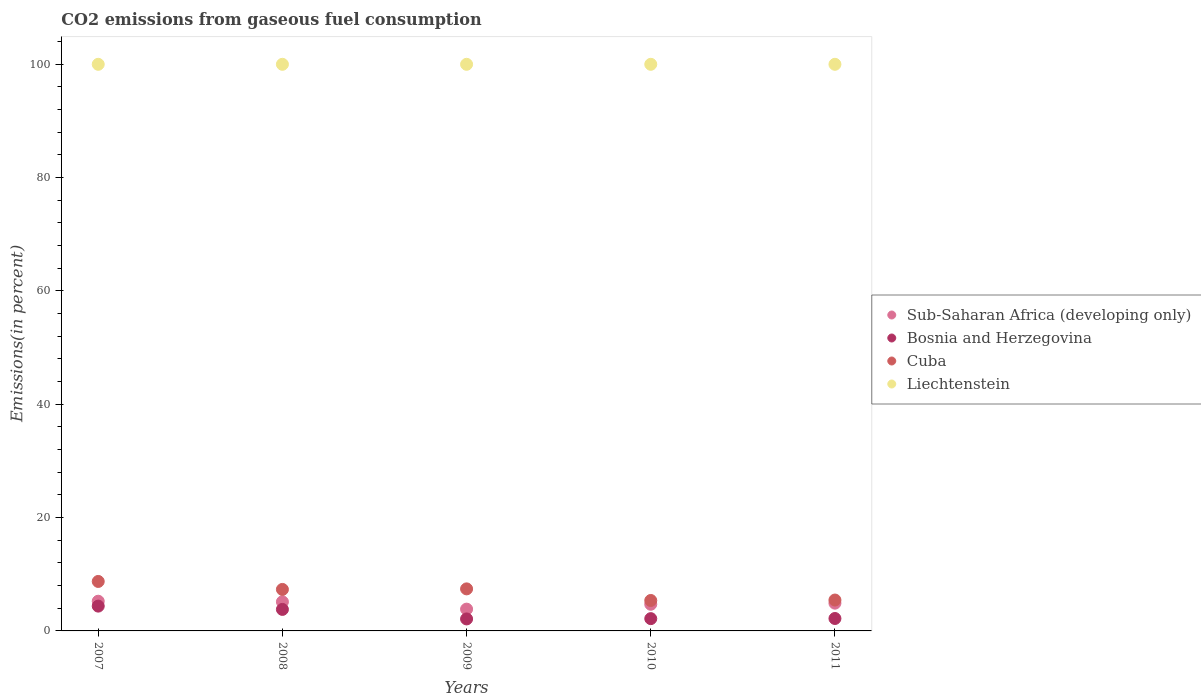What is the total CO2 emitted in Bosnia and Herzegovina in 2007?
Your answer should be very brief. 4.38. Across all years, what is the maximum total CO2 emitted in Bosnia and Herzegovina?
Offer a terse response. 4.38. Across all years, what is the minimum total CO2 emitted in Bosnia and Herzegovina?
Keep it short and to the point. 2.12. In which year was the total CO2 emitted in Liechtenstein maximum?
Give a very brief answer. 2007. In which year was the total CO2 emitted in Sub-Saharan Africa (developing only) minimum?
Your response must be concise. 2009. What is the total total CO2 emitted in Liechtenstein in the graph?
Offer a very short reply. 500. What is the difference between the total CO2 emitted in Cuba in 2009 and that in 2010?
Give a very brief answer. 2.05. What is the difference between the total CO2 emitted in Cuba in 2008 and the total CO2 emitted in Liechtenstein in 2007?
Keep it short and to the point. -92.68. What is the average total CO2 emitted in Bosnia and Herzegovina per year?
Your response must be concise. 2.93. In the year 2007, what is the difference between the total CO2 emitted in Bosnia and Herzegovina and total CO2 emitted in Liechtenstein?
Your response must be concise. -95.62. In how many years, is the total CO2 emitted in Liechtenstein greater than 32 %?
Ensure brevity in your answer.  5. What is the ratio of the total CO2 emitted in Sub-Saharan Africa (developing only) in 2009 to that in 2011?
Provide a succinct answer. 0.79. Is the total CO2 emitted in Bosnia and Herzegovina in 2010 less than that in 2011?
Offer a very short reply. Yes. What is the difference between the highest and the second highest total CO2 emitted in Bosnia and Herzegovina?
Provide a succinct answer. 0.58. Is the sum of the total CO2 emitted in Liechtenstein in 2009 and 2011 greater than the maximum total CO2 emitted in Sub-Saharan Africa (developing only) across all years?
Ensure brevity in your answer.  Yes. Is it the case that in every year, the sum of the total CO2 emitted in Cuba and total CO2 emitted in Liechtenstein  is greater than the total CO2 emitted in Sub-Saharan Africa (developing only)?
Offer a very short reply. Yes. Does the total CO2 emitted in Bosnia and Herzegovina monotonically increase over the years?
Offer a terse response. No. Is the total CO2 emitted in Liechtenstein strictly greater than the total CO2 emitted in Sub-Saharan Africa (developing only) over the years?
Give a very brief answer. Yes. How many dotlines are there?
Offer a very short reply. 4. How many years are there in the graph?
Make the answer very short. 5. What is the difference between two consecutive major ticks on the Y-axis?
Keep it short and to the point. 20. Are the values on the major ticks of Y-axis written in scientific E-notation?
Offer a terse response. No. Does the graph contain any zero values?
Give a very brief answer. No. Where does the legend appear in the graph?
Your response must be concise. Center right. How many legend labels are there?
Your answer should be very brief. 4. How are the legend labels stacked?
Keep it short and to the point. Vertical. What is the title of the graph?
Offer a very short reply. CO2 emissions from gaseous fuel consumption. What is the label or title of the X-axis?
Provide a succinct answer. Years. What is the label or title of the Y-axis?
Provide a succinct answer. Emissions(in percent). What is the Emissions(in percent) of Sub-Saharan Africa (developing only) in 2007?
Your answer should be compact. 5.24. What is the Emissions(in percent) in Bosnia and Herzegovina in 2007?
Ensure brevity in your answer.  4.38. What is the Emissions(in percent) of Cuba in 2007?
Your answer should be very brief. 8.73. What is the Emissions(in percent) in Liechtenstein in 2007?
Your response must be concise. 100. What is the Emissions(in percent) of Sub-Saharan Africa (developing only) in 2008?
Give a very brief answer. 5.14. What is the Emissions(in percent) of Bosnia and Herzegovina in 2008?
Offer a terse response. 3.8. What is the Emissions(in percent) in Cuba in 2008?
Ensure brevity in your answer.  7.32. What is the Emissions(in percent) of Liechtenstein in 2008?
Keep it short and to the point. 100. What is the Emissions(in percent) of Sub-Saharan Africa (developing only) in 2009?
Keep it short and to the point. 3.85. What is the Emissions(in percent) of Bosnia and Herzegovina in 2009?
Provide a succinct answer. 2.12. What is the Emissions(in percent) in Cuba in 2009?
Your answer should be very brief. 7.42. What is the Emissions(in percent) in Liechtenstein in 2009?
Ensure brevity in your answer.  100. What is the Emissions(in percent) of Sub-Saharan Africa (developing only) in 2010?
Offer a very short reply. 4.71. What is the Emissions(in percent) of Bosnia and Herzegovina in 2010?
Your response must be concise. 2.17. What is the Emissions(in percent) of Cuba in 2010?
Keep it short and to the point. 5.37. What is the Emissions(in percent) of Liechtenstein in 2010?
Your answer should be very brief. 100. What is the Emissions(in percent) of Sub-Saharan Africa (developing only) in 2011?
Provide a succinct answer. 4.9. What is the Emissions(in percent) of Bosnia and Herzegovina in 2011?
Make the answer very short. 2.19. What is the Emissions(in percent) in Cuba in 2011?
Your response must be concise. 5.45. What is the Emissions(in percent) in Liechtenstein in 2011?
Offer a very short reply. 100. Across all years, what is the maximum Emissions(in percent) in Sub-Saharan Africa (developing only)?
Provide a succinct answer. 5.24. Across all years, what is the maximum Emissions(in percent) of Bosnia and Herzegovina?
Offer a very short reply. 4.38. Across all years, what is the maximum Emissions(in percent) of Cuba?
Provide a short and direct response. 8.73. Across all years, what is the minimum Emissions(in percent) of Sub-Saharan Africa (developing only)?
Your answer should be very brief. 3.85. Across all years, what is the minimum Emissions(in percent) in Bosnia and Herzegovina?
Your response must be concise. 2.12. Across all years, what is the minimum Emissions(in percent) in Cuba?
Offer a very short reply. 5.37. What is the total Emissions(in percent) of Sub-Saharan Africa (developing only) in the graph?
Your response must be concise. 23.83. What is the total Emissions(in percent) in Bosnia and Herzegovina in the graph?
Keep it short and to the point. 14.65. What is the total Emissions(in percent) of Cuba in the graph?
Your answer should be compact. 34.3. What is the total Emissions(in percent) of Liechtenstein in the graph?
Make the answer very short. 500. What is the difference between the Emissions(in percent) in Sub-Saharan Africa (developing only) in 2007 and that in 2008?
Offer a very short reply. 0.1. What is the difference between the Emissions(in percent) in Bosnia and Herzegovina in 2007 and that in 2008?
Keep it short and to the point. 0.58. What is the difference between the Emissions(in percent) of Cuba in 2007 and that in 2008?
Provide a succinct answer. 1.41. What is the difference between the Emissions(in percent) of Liechtenstein in 2007 and that in 2008?
Ensure brevity in your answer.  0. What is the difference between the Emissions(in percent) of Sub-Saharan Africa (developing only) in 2007 and that in 2009?
Provide a short and direct response. 1.39. What is the difference between the Emissions(in percent) in Bosnia and Herzegovina in 2007 and that in 2009?
Give a very brief answer. 2.26. What is the difference between the Emissions(in percent) of Cuba in 2007 and that in 2009?
Offer a very short reply. 1.31. What is the difference between the Emissions(in percent) in Liechtenstein in 2007 and that in 2009?
Offer a very short reply. 0. What is the difference between the Emissions(in percent) of Sub-Saharan Africa (developing only) in 2007 and that in 2010?
Your answer should be compact. 0.54. What is the difference between the Emissions(in percent) of Bosnia and Herzegovina in 2007 and that in 2010?
Offer a terse response. 2.21. What is the difference between the Emissions(in percent) in Cuba in 2007 and that in 2010?
Make the answer very short. 3.36. What is the difference between the Emissions(in percent) of Sub-Saharan Africa (developing only) in 2007 and that in 2011?
Keep it short and to the point. 0.34. What is the difference between the Emissions(in percent) in Bosnia and Herzegovina in 2007 and that in 2011?
Your response must be concise. 2.19. What is the difference between the Emissions(in percent) of Cuba in 2007 and that in 2011?
Offer a very short reply. 3.28. What is the difference between the Emissions(in percent) of Sub-Saharan Africa (developing only) in 2008 and that in 2009?
Your response must be concise. 1.29. What is the difference between the Emissions(in percent) in Bosnia and Herzegovina in 2008 and that in 2009?
Give a very brief answer. 1.68. What is the difference between the Emissions(in percent) in Cuba in 2008 and that in 2009?
Offer a very short reply. -0.1. What is the difference between the Emissions(in percent) in Sub-Saharan Africa (developing only) in 2008 and that in 2010?
Your answer should be compact. 0.43. What is the difference between the Emissions(in percent) in Bosnia and Herzegovina in 2008 and that in 2010?
Your response must be concise. 1.63. What is the difference between the Emissions(in percent) of Cuba in 2008 and that in 2010?
Provide a short and direct response. 1.95. What is the difference between the Emissions(in percent) in Liechtenstein in 2008 and that in 2010?
Your answer should be compact. 0. What is the difference between the Emissions(in percent) of Sub-Saharan Africa (developing only) in 2008 and that in 2011?
Make the answer very short. 0.24. What is the difference between the Emissions(in percent) of Bosnia and Herzegovina in 2008 and that in 2011?
Keep it short and to the point. 1.6. What is the difference between the Emissions(in percent) in Cuba in 2008 and that in 2011?
Your answer should be very brief. 1.87. What is the difference between the Emissions(in percent) in Liechtenstein in 2008 and that in 2011?
Your response must be concise. 0. What is the difference between the Emissions(in percent) in Sub-Saharan Africa (developing only) in 2009 and that in 2010?
Offer a terse response. -0.86. What is the difference between the Emissions(in percent) of Bosnia and Herzegovina in 2009 and that in 2010?
Make the answer very short. -0.05. What is the difference between the Emissions(in percent) of Cuba in 2009 and that in 2010?
Provide a short and direct response. 2.05. What is the difference between the Emissions(in percent) of Sub-Saharan Africa (developing only) in 2009 and that in 2011?
Provide a succinct answer. -1.05. What is the difference between the Emissions(in percent) of Bosnia and Herzegovina in 2009 and that in 2011?
Offer a terse response. -0.08. What is the difference between the Emissions(in percent) of Cuba in 2009 and that in 2011?
Provide a succinct answer. 1.97. What is the difference between the Emissions(in percent) in Liechtenstein in 2009 and that in 2011?
Your answer should be very brief. 0. What is the difference between the Emissions(in percent) of Sub-Saharan Africa (developing only) in 2010 and that in 2011?
Keep it short and to the point. -0.19. What is the difference between the Emissions(in percent) in Bosnia and Herzegovina in 2010 and that in 2011?
Make the answer very short. -0.03. What is the difference between the Emissions(in percent) of Cuba in 2010 and that in 2011?
Your answer should be very brief. -0.08. What is the difference between the Emissions(in percent) of Sub-Saharan Africa (developing only) in 2007 and the Emissions(in percent) of Bosnia and Herzegovina in 2008?
Provide a succinct answer. 1.44. What is the difference between the Emissions(in percent) in Sub-Saharan Africa (developing only) in 2007 and the Emissions(in percent) in Cuba in 2008?
Your response must be concise. -2.08. What is the difference between the Emissions(in percent) in Sub-Saharan Africa (developing only) in 2007 and the Emissions(in percent) in Liechtenstein in 2008?
Offer a terse response. -94.76. What is the difference between the Emissions(in percent) of Bosnia and Herzegovina in 2007 and the Emissions(in percent) of Cuba in 2008?
Make the answer very short. -2.95. What is the difference between the Emissions(in percent) of Bosnia and Herzegovina in 2007 and the Emissions(in percent) of Liechtenstein in 2008?
Give a very brief answer. -95.62. What is the difference between the Emissions(in percent) of Cuba in 2007 and the Emissions(in percent) of Liechtenstein in 2008?
Offer a very short reply. -91.27. What is the difference between the Emissions(in percent) in Sub-Saharan Africa (developing only) in 2007 and the Emissions(in percent) in Bosnia and Herzegovina in 2009?
Provide a succinct answer. 3.12. What is the difference between the Emissions(in percent) in Sub-Saharan Africa (developing only) in 2007 and the Emissions(in percent) in Cuba in 2009?
Ensure brevity in your answer.  -2.18. What is the difference between the Emissions(in percent) of Sub-Saharan Africa (developing only) in 2007 and the Emissions(in percent) of Liechtenstein in 2009?
Your answer should be very brief. -94.76. What is the difference between the Emissions(in percent) of Bosnia and Herzegovina in 2007 and the Emissions(in percent) of Cuba in 2009?
Your answer should be compact. -3.04. What is the difference between the Emissions(in percent) in Bosnia and Herzegovina in 2007 and the Emissions(in percent) in Liechtenstein in 2009?
Your answer should be very brief. -95.62. What is the difference between the Emissions(in percent) of Cuba in 2007 and the Emissions(in percent) of Liechtenstein in 2009?
Provide a short and direct response. -91.27. What is the difference between the Emissions(in percent) of Sub-Saharan Africa (developing only) in 2007 and the Emissions(in percent) of Bosnia and Herzegovina in 2010?
Keep it short and to the point. 3.07. What is the difference between the Emissions(in percent) in Sub-Saharan Africa (developing only) in 2007 and the Emissions(in percent) in Cuba in 2010?
Offer a terse response. -0.13. What is the difference between the Emissions(in percent) in Sub-Saharan Africa (developing only) in 2007 and the Emissions(in percent) in Liechtenstein in 2010?
Keep it short and to the point. -94.76. What is the difference between the Emissions(in percent) of Bosnia and Herzegovina in 2007 and the Emissions(in percent) of Cuba in 2010?
Your answer should be very brief. -0.99. What is the difference between the Emissions(in percent) in Bosnia and Herzegovina in 2007 and the Emissions(in percent) in Liechtenstein in 2010?
Provide a succinct answer. -95.62. What is the difference between the Emissions(in percent) in Cuba in 2007 and the Emissions(in percent) in Liechtenstein in 2010?
Ensure brevity in your answer.  -91.27. What is the difference between the Emissions(in percent) of Sub-Saharan Africa (developing only) in 2007 and the Emissions(in percent) of Bosnia and Herzegovina in 2011?
Keep it short and to the point. 3.05. What is the difference between the Emissions(in percent) of Sub-Saharan Africa (developing only) in 2007 and the Emissions(in percent) of Cuba in 2011?
Keep it short and to the point. -0.21. What is the difference between the Emissions(in percent) in Sub-Saharan Africa (developing only) in 2007 and the Emissions(in percent) in Liechtenstein in 2011?
Provide a short and direct response. -94.76. What is the difference between the Emissions(in percent) in Bosnia and Herzegovina in 2007 and the Emissions(in percent) in Cuba in 2011?
Ensure brevity in your answer.  -1.07. What is the difference between the Emissions(in percent) in Bosnia and Herzegovina in 2007 and the Emissions(in percent) in Liechtenstein in 2011?
Keep it short and to the point. -95.62. What is the difference between the Emissions(in percent) of Cuba in 2007 and the Emissions(in percent) of Liechtenstein in 2011?
Provide a short and direct response. -91.27. What is the difference between the Emissions(in percent) of Sub-Saharan Africa (developing only) in 2008 and the Emissions(in percent) of Bosnia and Herzegovina in 2009?
Keep it short and to the point. 3.02. What is the difference between the Emissions(in percent) of Sub-Saharan Africa (developing only) in 2008 and the Emissions(in percent) of Cuba in 2009?
Provide a succinct answer. -2.28. What is the difference between the Emissions(in percent) of Sub-Saharan Africa (developing only) in 2008 and the Emissions(in percent) of Liechtenstein in 2009?
Provide a short and direct response. -94.86. What is the difference between the Emissions(in percent) in Bosnia and Herzegovina in 2008 and the Emissions(in percent) in Cuba in 2009?
Keep it short and to the point. -3.62. What is the difference between the Emissions(in percent) in Bosnia and Herzegovina in 2008 and the Emissions(in percent) in Liechtenstein in 2009?
Offer a very short reply. -96.2. What is the difference between the Emissions(in percent) in Cuba in 2008 and the Emissions(in percent) in Liechtenstein in 2009?
Provide a short and direct response. -92.68. What is the difference between the Emissions(in percent) in Sub-Saharan Africa (developing only) in 2008 and the Emissions(in percent) in Bosnia and Herzegovina in 2010?
Your answer should be compact. 2.97. What is the difference between the Emissions(in percent) of Sub-Saharan Africa (developing only) in 2008 and the Emissions(in percent) of Cuba in 2010?
Ensure brevity in your answer.  -0.23. What is the difference between the Emissions(in percent) of Sub-Saharan Africa (developing only) in 2008 and the Emissions(in percent) of Liechtenstein in 2010?
Keep it short and to the point. -94.86. What is the difference between the Emissions(in percent) of Bosnia and Herzegovina in 2008 and the Emissions(in percent) of Cuba in 2010?
Your response must be concise. -1.58. What is the difference between the Emissions(in percent) of Bosnia and Herzegovina in 2008 and the Emissions(in percent) of Liechtenstein in 2010?
Offer a terse response. -96.2. What is the difference between the Emissions(in percent) in Cuba in 2008 and the Emissions(in percent) in Liechtenstein in 2010?
Your answer should be compact. -92.68. What is the difference between the Emissions(in percent) in Sub-Saharan Africa (developing only) in 2008 and the Emissions(in percent) in Bosnia and Herzegovina in 2011?
Make the answer very short. 2.95. What is the difference between the Emissions(in percent) of Sub-Saharan Africa (developing only) in 2008 and the Emissions(in percent) of Cuba in 2011?
Your answer should be very brief. -0.31. What is the difference between the Emissions(in percent) in Sub-Saharan Africa (developing only) in 2008 and the Emissions(in percent) in Liechtenstein in 2011?
Ensure brevity in your answer.  -94.86. What is the difference between the Emissions(in percent) of Bosnia and Herzegovina in 2008 and the Emissions(in percent) of Cuba in 2011?
Your answer should be compact. -1.65. What is the difference between the Emissions(in percent) in Bosnia and Herzegovina in 2008 and the Emissions(in percent) in Liechtenstein in 2011?
Ensure brevity in your answer.  -96.2. What is the difference between the Emissions(in percent) in Cuba in 2008 and the Emissions(in percent) in Liechtenstein in 2011?
Your answer should be compact. -92.68. What is the difference between the Emissions(in percent) in Sub-Saharan Africa (developing only) in 2009 and the Emissions(in percent) in Bosnia and Herzegovina in 2010?
Ensure brevity in your answer.  1.68. What is the difference between the Emissions(in percent) of Sub-Saharan Africa (developing only) in 2009 and the Emissions(in percent) of Cuba in 2010?
Offer a very short reply. -1.53. What is the difference between the Emissions(in percent) in Sub-Saharan Africa (developing only) in 2009 and the Emissions(in percent) in Liechtenstein in 2010?
Your answer should be very brief. -96.15. What is the difference between the Emissions(in percent) of Bosnia and Herzegovina in 2009 and the Emissions(in percent) of Cuba in 2010?
Ensure brevity in your answer.  -3.26. What is the difference between the Emissions(in percent) of Bosnia and Herzegovina in 2009 and the Emissions(in percent) of Liechtenstein in 2010?
Provide a succinct answer. -97.88. What is the difference between the Emissions(in percent) of Cuba in 2009 and the Emissions(in percent) of Liechtenstein in 2010?
Keep it short and to the point. -92.58. What is the difference between the Emissions(in percent) of Sub-Saharan Africa (developing only) in 2009 and the Emissions(in percent) of Bosnia and Herzegovina in 2011?
Your answer should be very brief. 1.65. What is the difference between the Emissions(in percent) in Sub-Saharan Africa (developing only) in 2009 and the Emissions(in percent) in Cuba in 2011?
Your answer should be very brief. -1.6. What is the difference between the Emissions(in percent) of Sub-Saharan Africa (developing only) in 2009 and the Emissions(in percent) of Liechtenstein in 2011?
Your response must be concise. -96.15. What is the difference between the Emissions(in percent) of Bosnia and Herzegovina in 2009 and the Emissions(in percent) of Cuba in 2011?
Make the answer very short. -3.33. What is the difference between the Emissions(in percent) of Bosnia and Herzegovina in 2009 and the Emissions(in percent) of Liechtenstein in 2011?
Keep it short and to the point. -97.88. What is the difference between the Emissions(in percent) of Cuba in 2009 and the Emissions(in percent) of Liechtenstein in 2011?
Your answer should be very brief. -92.58. What is the difference between the Emissions(in percent) of Sub-Saharan Africa (developing only) in 2010 and the Emissions(in percent) of Bosnia and Herzegovina in 2011?
Ensure brevity in your answer.  2.51. What is the difference between the Emissions(in percent) of Sub-Saharan Africa (developing only) in 2010 and the Emissions(in percent) of Cuba in 2011?
Offer a very short reply. -0.75. What is the difference between the Emissions(in percent) of Sub-Saharan Africa (developing only) in 2010 and the Emissions(in percent) of Liechtenstein in 2011?
Your answer should be compact. -95.29. What is the difference between the Emissions(in percent) of Bosnia and Herzegovina in 2010 and the Emissions(in percent) of Cuba in 2011?
Your answer should be compact. -3.28. What is the difference between the Emissions(in percent) in Bosnia and Herzegovina in 2010 and the Emissions(in percent) in Liechtenstein in 2011?
Your answer should be compact. -97.83. What is the difference between the Emissions(in percent) in Cuba in 2010 and the Emissions(in percent) in Liechtenstein in 2011?
Provide a short and direct response. -94.63. What is the average Emissions(in percent) of Sub-Saharan Africa (developing only) per year?
Offer a terse response. 4.77. What is the average Emissions(in percent) in Bosnia and Herzegovina per year?
Keep it short and to the point. 2.93. What is the average Emissions(in percent) in Cuba per year?
Your answer should be very brief. 6.86. What is the average Emissions(in percent) of Liechtenstein per year?
Your response must be concise. 100. In the year 2007, what is the difference between the Emissions(in percent) of Sub-Saharan Africa (developing only) and Emissions(in percent) of Bosnia and Herzegovina?
Your response must be concise. 0.86. In the year 2007, what is the difference between the Emissions(in percent) in Sub-Saharan Africa (developing only) and Emissions(in percent) in Cuba?
Your answer should be very brief. -3.49. In the year 2007, what is the difference between the Emissions(in percent) of Sub-Saharan Africa (developing only) and Emissions(in percent) of Liechtenstein?
Give a very brief answer. -94.76. In the year 2007, what is the difference between the Emissions(in percent) of Bosnia and Herzegovina and Emissions(in percent) of Cuba?
Your answer should be compact. -4.35. In the year 2007, what is the difference between the Emissions(in percent) of Bosnia and Herzegovina and Emissions(in percent) of Liechtenstein?
Your answer should be very brief. -95.62. In the year 2007, what is the difference between the Emissions(in percent) in Cuba and Emissions(in percent) in Liechtenstein?
Provide a succinct answer. -91.27. In the year 2008, what is the difference between the Emissions(in percent) of Sub-Saharan Africa (developing only) and Emissions(in percent) of Bosnia and Herzegovina?
Ensure brevity in your answer.  1.34. In the year 2008, what is the difference between the Emissions(in percent) in Sub-Saharan Africa (developing only) and Emissions(in percent) in Cuba?
Offer a terse response. -2.19. In the year 2008, what is the difference between the Emissions(in percent) of Sub-Saharan Africa (developing only) and Emissions(in percent) of Liechtenstein?
Give a very brief answer. -94.86. In the year 2008, what is the difference between the Emissions(in percent) in Bosnia and Herzegovina and Emissions(in percent) in Cuba?
Keep it short and to the point. -3.53. In the year 2008, what is the difference between the Emissions(in percent) in Bosnia and Herzegovina and Emissions(in percent) in Liechtenstein?
Provide a succinct answer. -96.2. In the year 2008, what is the difference between the Emissions(in percent) in Cuba and Emissions(in percent) in Liechtenstein?
Your answer should be compact. -92.68. In the year 2009, what is the difference between the Emissions(in percent) in Sub-Saharan Africa (developing only) and Emissions(in percent) in Bosnia and Herzegovina?
Provide a succinct answer. 1.73. In the year 2009, what is the difference between the Emissions(in percent) of Sub-Saharan Africa (developing only) and Emissions(in percent) of Cuba?
Provide a succinct answer. -3.57. In the year 2009, what is the difference between the Emissions(in percent) in Sub-Saharan Africa (developing only) and Emissions(in percent) in Liechtenstein?
Provide a succinct answer. -96.15. In the year 2009, what is the difference between the Emissions(in percent) in Bosnia and Herzegovina and Emissions(in percent) in Cuba?
Provide a short and direct response. -5.3. In the year 2009, what is the difference between the Emissions(in percent) of Bosnia and Herzegovina and Emissions(in percent) of Liechtenstein?
Provide a short and direct response. -97.88. In the year 2009, what is the difference between the Emissions(in percent) in Cuba and Emissions(in percent) in Liechtenstein?
Provide a short and direct response. -92.58. In the year 2010, what is the difference between the Emissions(in percent) in Sub-Saharan Africa (developing only) and Emissions(in percent) in Bosnia and Herzegovina?
Keep it short and to the point. 2.54. In the year 2010, what is the difference between the Emissions(in percent) in Sub-Saharan Africa (developing only) and Emissions(in percent) in Cuba?
Your answer should be compact. -0.67. In the year 2010, what is the difference between the Emissions(in percent) of Sub-Saharan Africa (developing only) and Emissions(in percent) of Liechtenstein?
Your answer should be very brief. -95.29. In the year 2010, what is the difference between the Emissions(in percent) of Bosnia and Herzegovina and Emissions(in percent) of Cuba?
Ensure brevity in your answer.  -3.2. In the year 2010, what is the difference between the Emissions(in percent) of Bosnia and Herzegovina and Emissions(in percent) of Liechtenstein?
Ensure brevity in your answer.  -97.83. In the year 2010, what is the difference between the Emissions(in percent) in Cuba and Emissions(in percent) in Liechtenstein?
Offer a very short reply. -94.63. In the year 2011, what is the difference between the Emissions(in percent) in Sub-Saharan Africa (developing only) and Emissions(in percent) in Bosnia and Herzegovina?
Your answer should be compact. 2.71. In the year 2011, what is the difference between the Emissions(in percent) of Sub-Saharan Africa (developing only) and Emissions(in percent) of Cuba?
Offer a very short reply. -0.55. In the year 2011, what is the difference between the Emissions(in percent) in Sub-Saharan Africa (developing only) and Emissions(in percent) in Liechtenstein?
Provide a short and direct response. -95.1. In the year 2011, what is the difference between the Emissions(in percent) of Bosnia and Herzegovina and Emissions(in percent) of Cuba?
Provide a succinct answer. -3.26. In the year 2011, what is the difference between the Emissions(in percent) in Bosnia and Herzegovina and Emissions(in percent) in Liechtenstein?
Make the answer very short. -97.81. In the year 2011, what is the difference between the Emissions(in percent) in Cuba and Emissions(in percent) in Liechtenstein?
Your answer should be compact. -94.55. What is the ratio of the Emissions(in percent) of Sub-Saharan Africa (developing only) in 2007 to that in 2008?
Provide a succinct answer. 1.02. What is the ratio of the Emissions(in percent) in Bosnia and Herzegovina in 2007 to that in 2008?
Your answer should be very brief. 1.15. What is the ratio of the Emissions(in percent) of Cuba in 2007 to that in 2008?
Your response must be concise. 1.19. What is the ratio of the Emissions(in percent) of Liechtenstein in 2007 to that in 2008?
Keep it short and to the point. 1. What is the ratio of the Emissions(in percent) of Sub-Saharan Africa (developing only) in 2007 to that in 2009?
Make the answer very short. 1.36. What is the ratio of the Emissions(in percent) in Bosnia and Herzegovina in 2007 to that in 2009?
Keep it short and to the point. 2.07. What is the ratio of the Emissions(in percent) of Cuba in 2007 to that in 2009?
Provide a succinct answer. 1.18. What is the ratio of the Emissions(in percent) in Sub-Saharan Africa (developing only) in 2007 to that in 2010?
Your answer should be compact. 1.11. What is the ratio of the Emissions(in percent) of Bosnia and Herzegovina in 2007 to that in 2010?
Make the answer very short. 2.02. What is the ratio of the Emissions(in percent) of Cuba in 2007 to that in 2010?
Ensure brevity in your answer.  1.63. What is the ratio of the Emissions(in percent) of Liechtenstein in 2007 to that in 2010?
Your answer should be very brief. 1. What is the ratio of the Emissions(in percent) of Sub-Saharan Africa (developing only) in 2007 to that in 2011?
Your response must be concise. 1.07. What is the ratio of the Emissions(in percent) of Bosnia and Herzegovina in 2007 to that in 2011?
Provide a short and direct response. 2. What is the ratio of the Emissions(in percent) in Cuba in 2007 to that in 2011?
Offer a terse response. 1.6. What is the ratio of the Emissions(in percent) in Liechtenstein in 2007 to that in 2011?
Provide a succinct answer. 1. What is the ratio of the Emissions(in percent) of Sub-Saharan Africa (developing only) in 2008 to that in 2009?
Your answer should be very brief. 1.34. What is the ratio of the Emissions(in percent) of Bosnia and Herzegovina in 2008 to that in 2009?
Your response must be concise. 1.79. What is the ratio of the Emissions(in percent) of Cuba in 2008 to that in 2009?
Make the answer very short. 0.99. What is the ratio of the Emissions(in percent) of Sub-Saharan Africa (developing only) in 2008 to that in 2010?
Provide a succinct answer. 1.09. What is the ratio of the Emissions(in percent) of Bosnia and Herzegovina in 2008 to that in 2010?
Make the answer very short. 1.75. What is the ratio of the Emissions(in percent) in Cuba in 2008 to that in 2010?
Keep it short and to the point. 1.36. What is the ratio of the Emissions(in percent) in Sub-Saharan Africa (developing only) in 2008 to that in 2011?
Make the answer very short. 1.05. What is the ratio of the Emissions(in percent) of Bosnia and Herzegovina in 2008 to that in 2011?
Your answer should be compact. 1.73. What is the ratio of the Emissions(in percent) of Cuba in 2008 to that in 2011?
Make the answer very short. 1.34. What is the ratio of the Emissions(in percent) of Liechtenstein in 2008 to that in 2011?
Your answer should be very brief. 1. What is the ratio of the Emissions(in percent) of Sub-Saharan Africa (developing only) in 2009 to that in 2010?
Provide a short and direct response. 0.82. What is the ratio of the Emissions(in percent) of Bosnia and Herzegovina in 2009 to that in 2010?
Provide a succinct answer. 0.98. What is the ratio of the Emissions(in percent) of Cuba in 2009 to that in 2010?
Offer a terse response. 1.38. What is the ratio of the Emissions(in percent) of Liechtenstein in 2009 to that in 2010?
Keep it short and to the point. 1. What is the ratio of the Emissions(in percent) of Sub-Saharan Africa (developing only) in 2009 to that in 2011?
Offer a terse response. 0.79. What is the ratio of the Emissions(in percent) in Bosnia and Herzegovina in 2009 to that in 2011?
Give a very brief answer. 0.97. What is the ratio of the Emissions(in percent) in Cuba in 2009 to that in 2011?
Ensure brevity in your answer.  1.36. What is the ratio of the Emissions(in percent) of Liechtenstein in 2009 to that in 2011?
Your answer should be compact. 1. What is the ratio of the Emissions(in percent) of Sub-Saharan Africa (developing only) in 2010 to that in 2011?
Give a very brief answer. 0.96. What is the ratio of the Emissions(in percent) in Cuba in 2010 to that in 2011?
Provide a succinct answer. 0.99. What is the difference between the highest and the second highest Emissions(in percent) in Sub-Saharan Africa (developing only)?
Your answer should be very brief. 0.1. What is the difference between the highest and the second highest Emissions(in percent) of Bosnia and Herzegovina?
Make the answer very short. 0.58. What is the difference between the highest and the second highest Emissions(in percent) of Cuba?
Provide a succinct answer. 1.31. What is the difference between the highest and the lowest Emissions(in percent) of Sub-Saharan Africa (developing only)?
Provide a short and direct response. 1.39. What is the difference between the highest and the lowest Emissions(in percent) of Bosnia and Herzegovina?
Your answer should be very brief. 2.26. What is the difference between the highest and the lowest Emissions(in percent) of Cuba?
Keep it short and to the point. 3.36. What is the difference between the highest and the lowest Emissions(in percent) of Liechtenstein?
Keep it short and to the point. 0. 